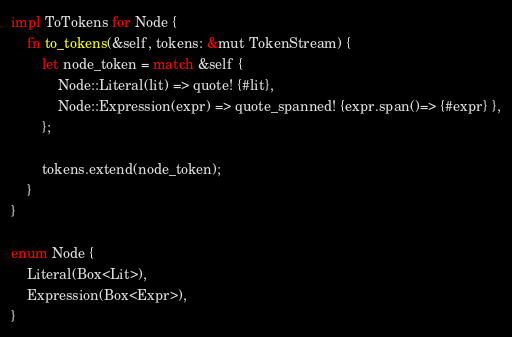<code> <loc_0><loc_0><loc_500><loc_500><_Rust_>impl ToTokens for Node {
    fn to_tokens(&self, tokens: &mut TokenStream) {
        let node_token = match &self {
            Node::Literal(lit) => quote! {#lit},
            Node::Expression(expr) => quote_spanned! {expr.span()=> {#expr} },
        };

        tokens.extend(node_token);
    }
}

enum Node {
    Literal(Box<Lit>),
    Expression(Box<Expr>),
}
</code> 